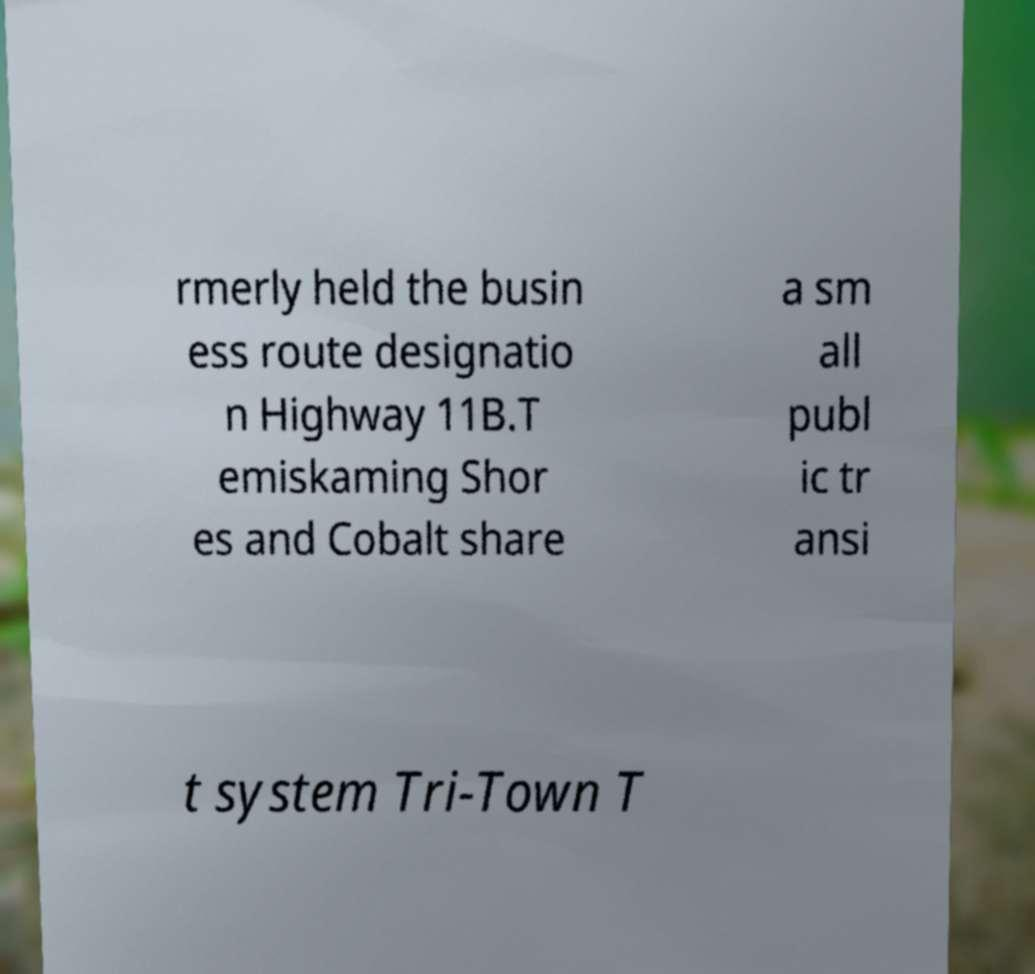Please identify and transcribe the text found in this image. rmerly held the busin ess route designatio n Highway 11B.T emiskaming Shor es and Cobalt share a sm all publ ic tr ansi t system Tri-Town T 